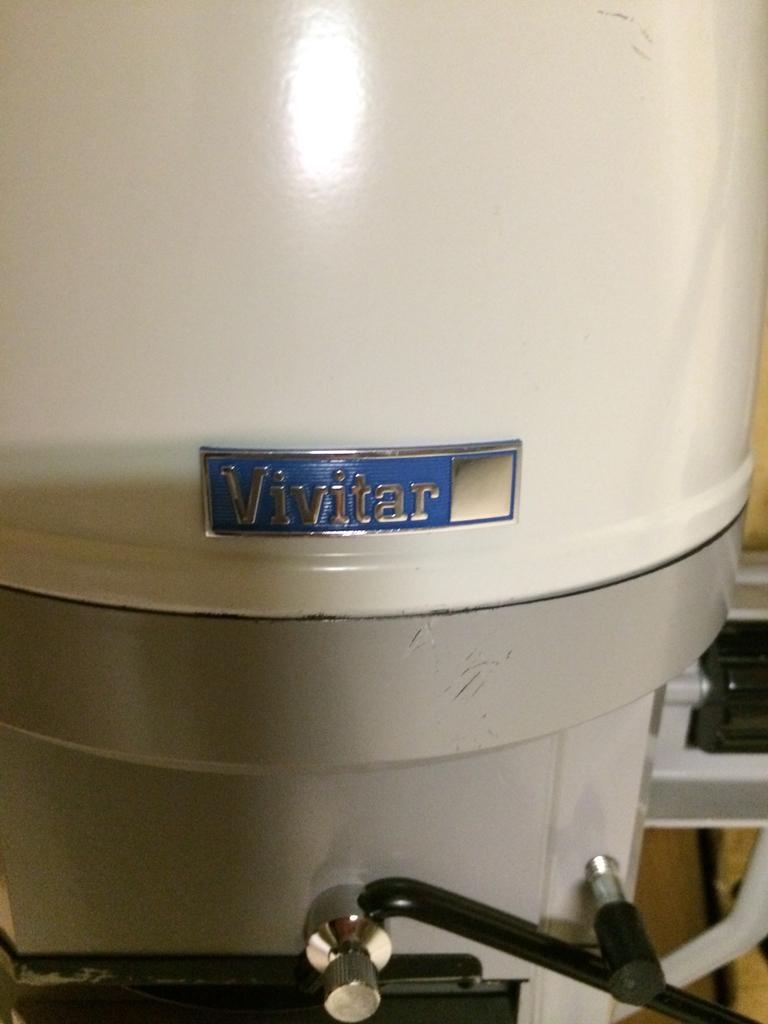<image>
Provide a brief description of the given image. a machine with the name Vivitar on the side of it 